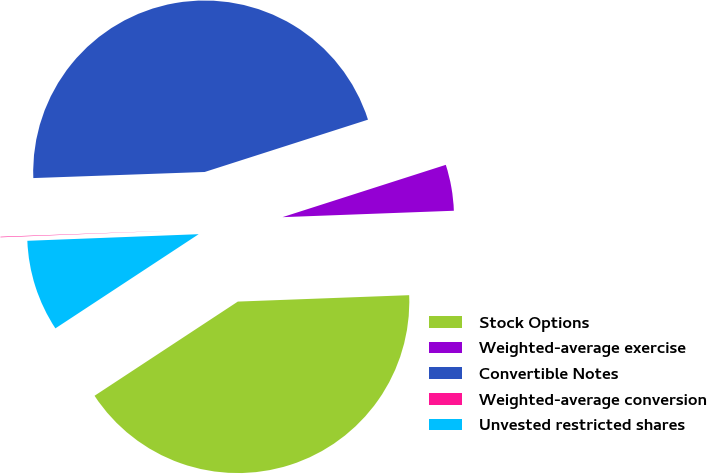Convert chart to OTSL. <chart><loc_0><loc_0><loc_500><loc_500><pie_chart><fcel>Stock Options<fcel>Weighted-average exercise<fcel>Convertible Notes<fcel>Weighted-average conversion<fcel>Unvested restricted shares<nl><fcel>41.34%<fcel>4.34%<fcel>45.63%<fcel>0.05%<fcel>8.64%<nl></chart> 